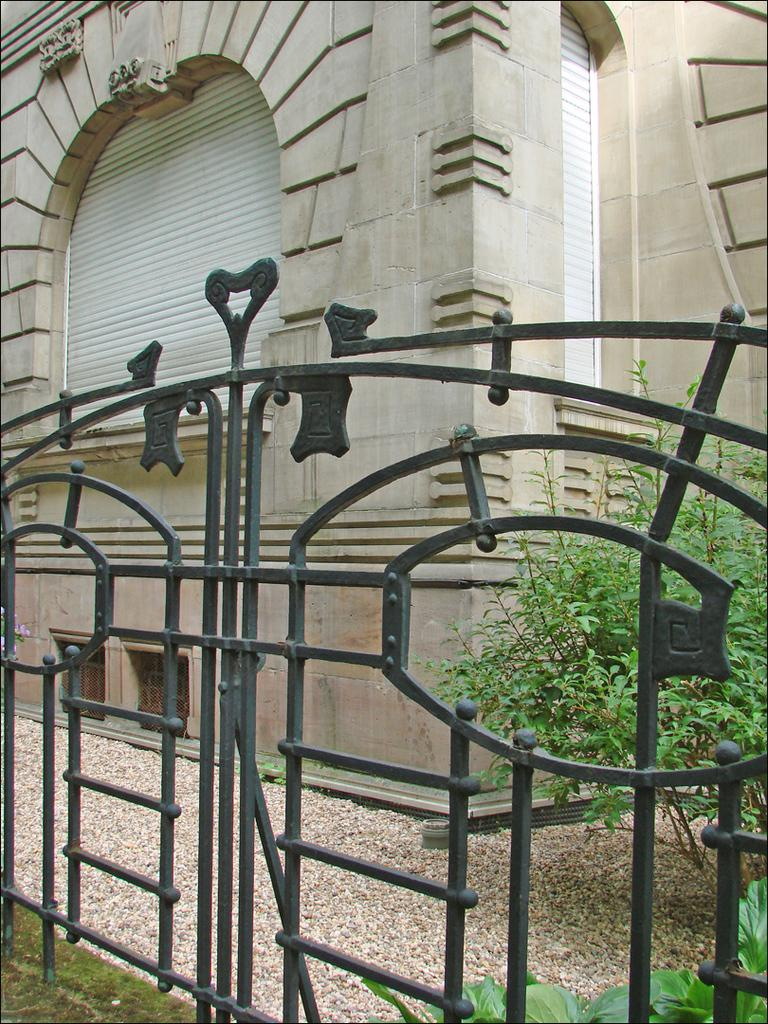What is located in the foreground of the image? There is a gate in the foreground of the image. What is visible in the background of the image? There is a building in the background of the image. Can you describe any natural elements in the image? There is a plant and grass at the bottom of the image. What type of material is present in the image? There are stones in the image. How many flags can be seen on the train in the image? There is no train or flag present in the image. What type of rings are visible on the plant in the image? There are no rings visible on the plant in the image. 